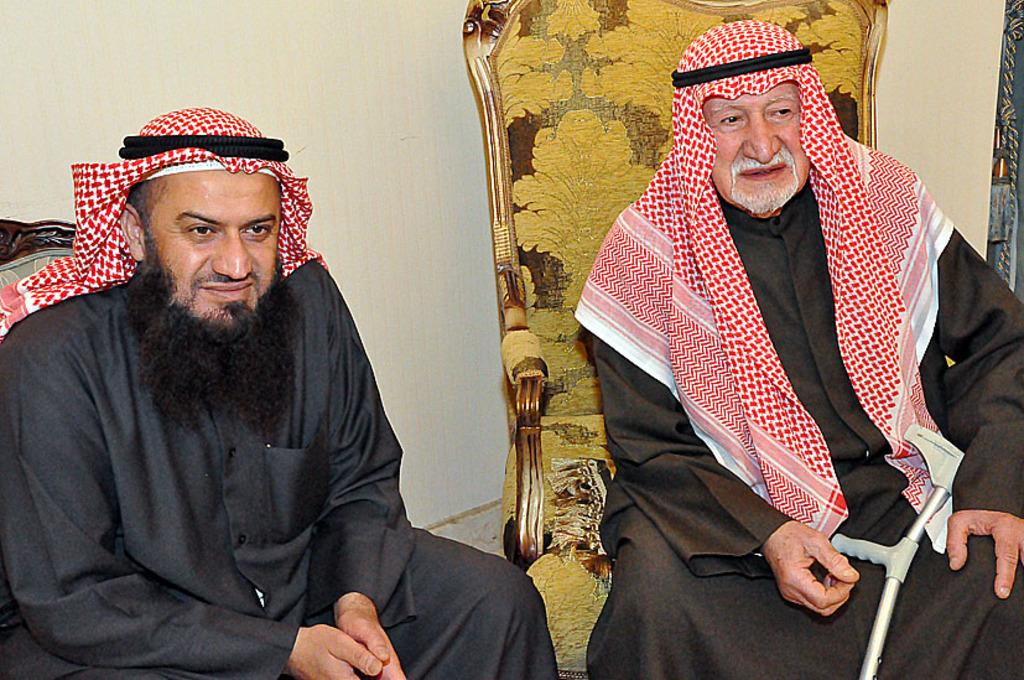How many people are in the image? There are two persons in the image. What color are the dresses worn by the persons? Both persons are wearing black color dresses. What are the persons doing in the image? The persons are sitting on chairs. What can be seen in the background of the image? There is a wall in the background of the image. Is the queen present in the image? There is no queen present in the image. What type of card is being used by the persons in the image? There are no cards visible in the image. 